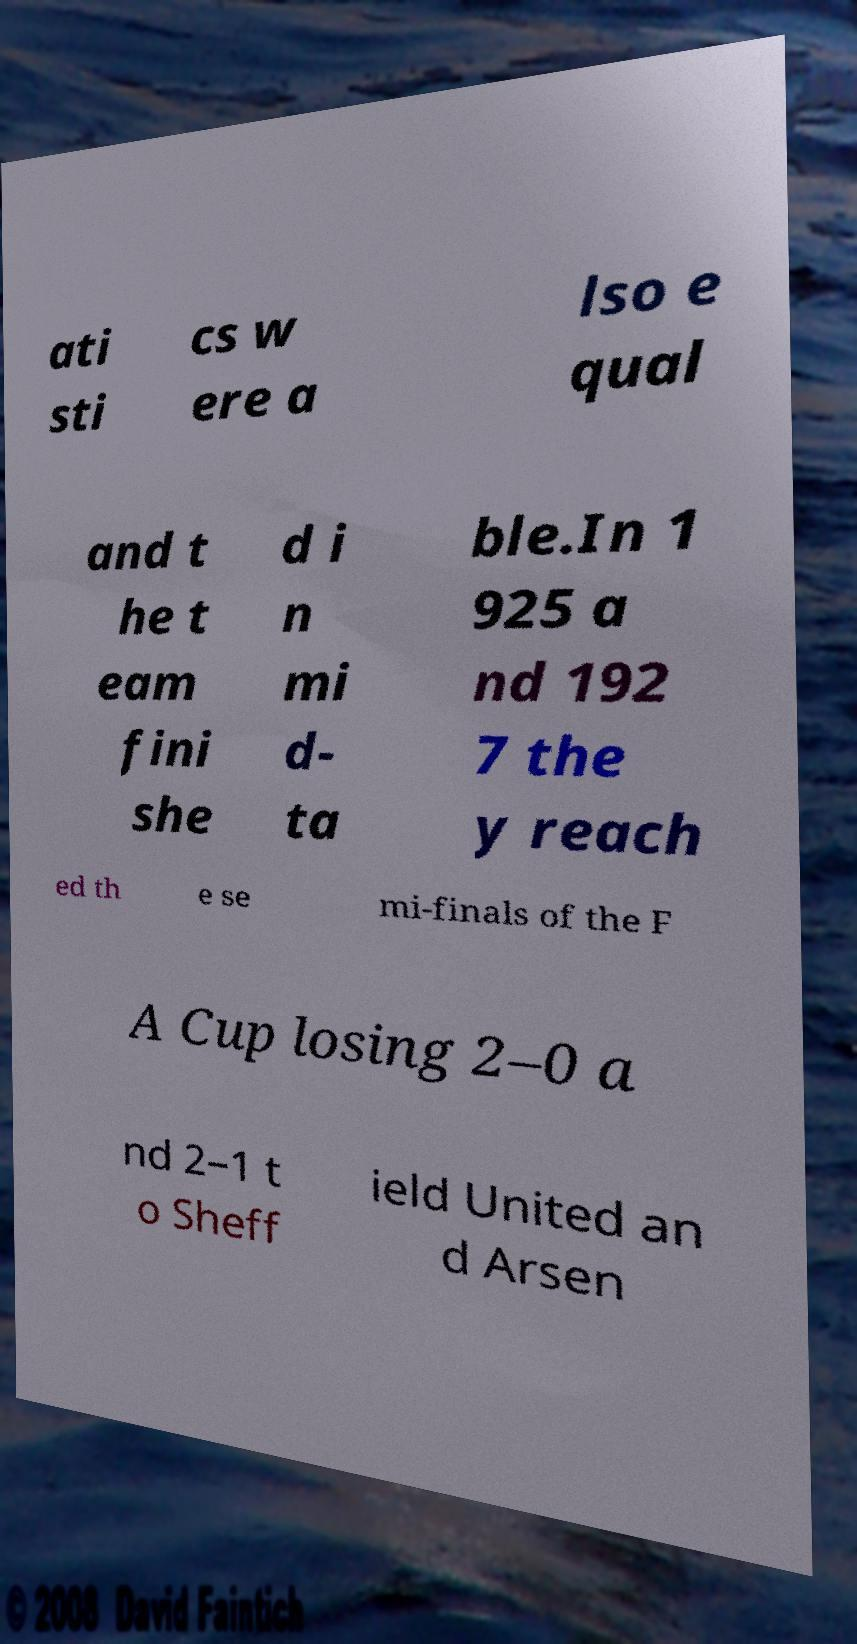Please read and relay the text visible in this image. What does it say? ati sti cs w ere a lso e qual and t he t eam fini she d i n mi d- ta ble.In 1 925 a nd 192 7 the y reach ed th e se mi-finals of the F A Cup losing 2–0 a nd 2–1 t o Sheff ield United an d Arsen 